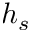<formula> <loc_0><loc_0><loc_500><loc_500>h _ { s }</formula> 